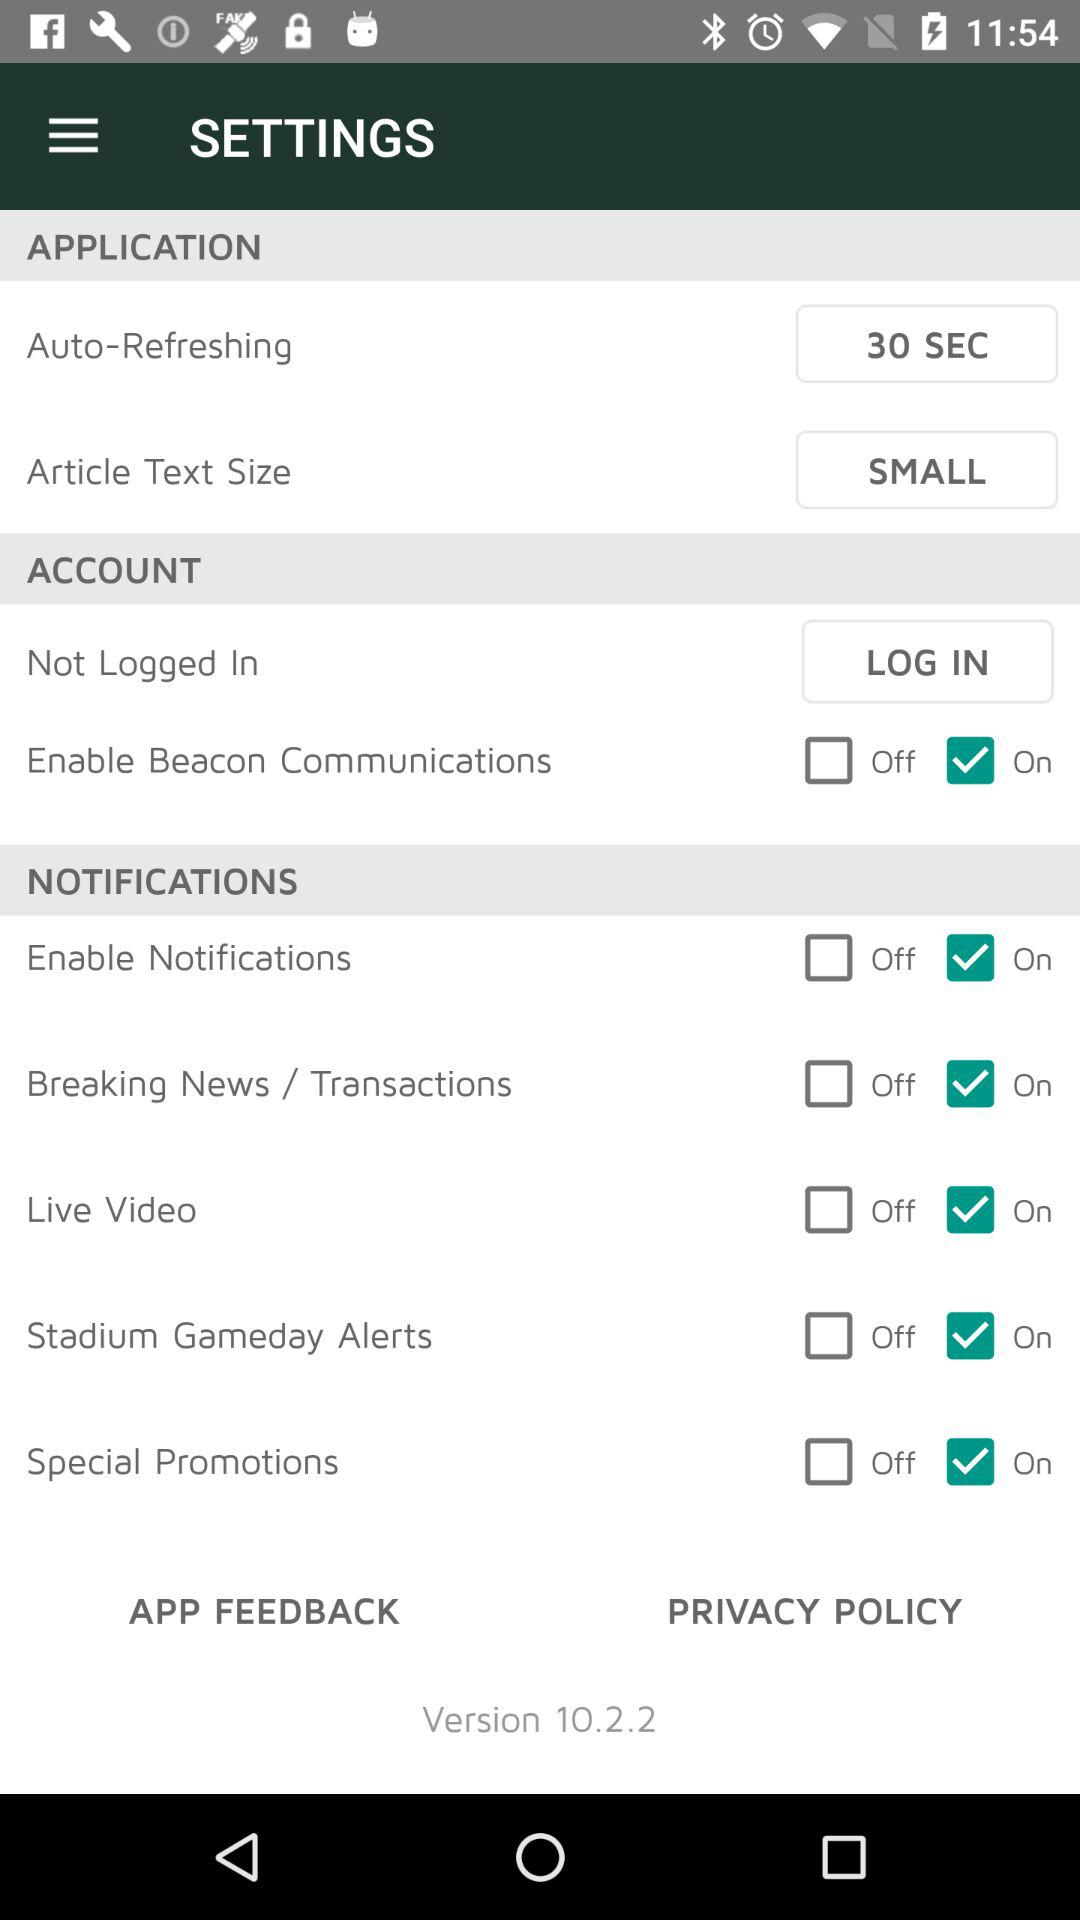What version is used? The version is 10.2.2. 